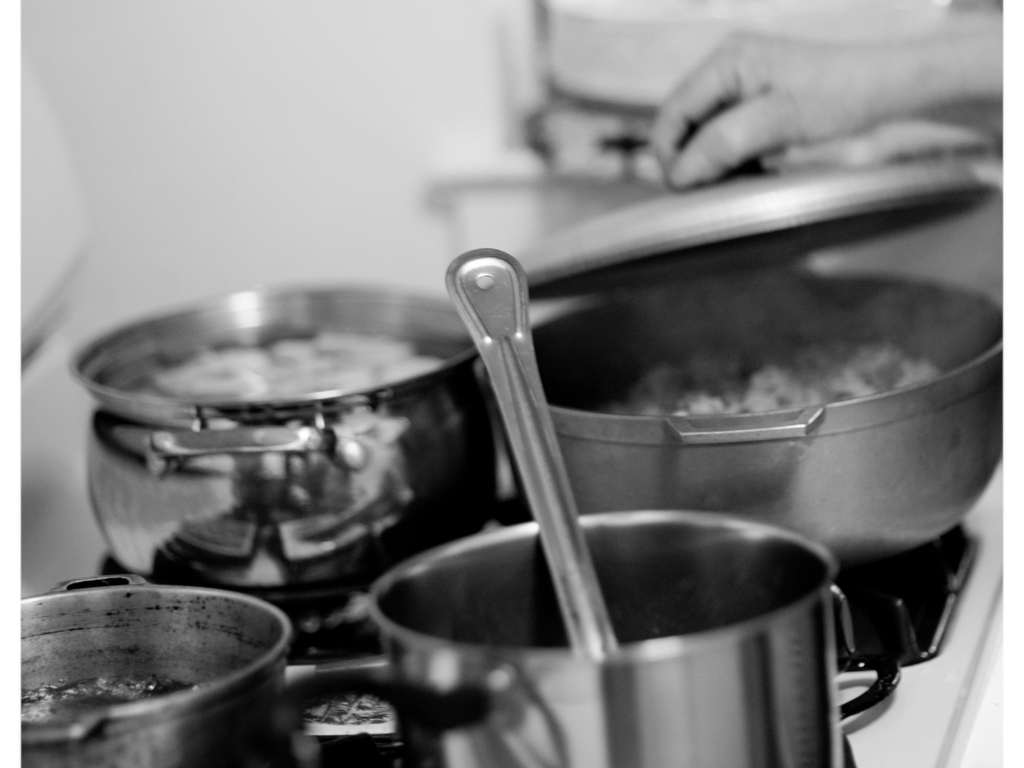What narrative could be inferred from the visible human elements and the arrangement of pots? The visible human elements, such as hands working in the background, coupled with the strategic arrangement of various pots and kitchen tools, narrate a story of culinary dedication and daily life. This arrangement can suggest a multi-tasking individual possibly preparing multiple dishes simultaneously, which portrays a dynamic and perhaps familial domestic setting. It evokes a sense of tradition and the daily ritual of meal preparation. 